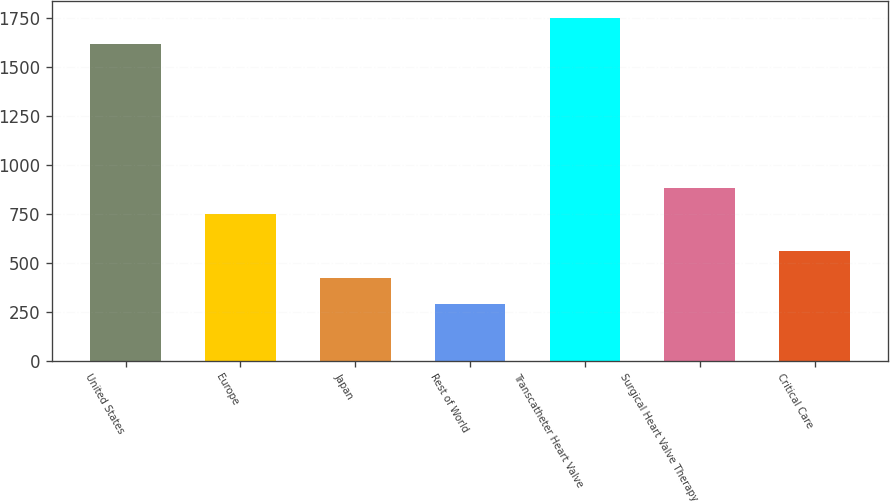Convert chart to OTSL. <chart><loc_0><loc_0><loc_500><loc_500><bar_chart><fcel>United States<fcel>Europe<fcel>Japan<fcel>Rest of World<fcel>Transcatheter Heart Valve<fcel>Surgical Heart Valve Therapy<fcel>Critical Care<nl><fcel>1615.7<fcel>749<fcel>423.58<fcel>289.7<fcel>1749.58<fcel>882.88<fcel>560.3<nl></chart> 